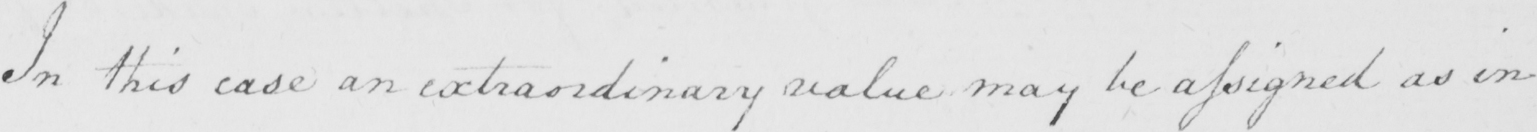Can you read and transcribe this handwriting? In this case an extraordinary value may be assigned as in 